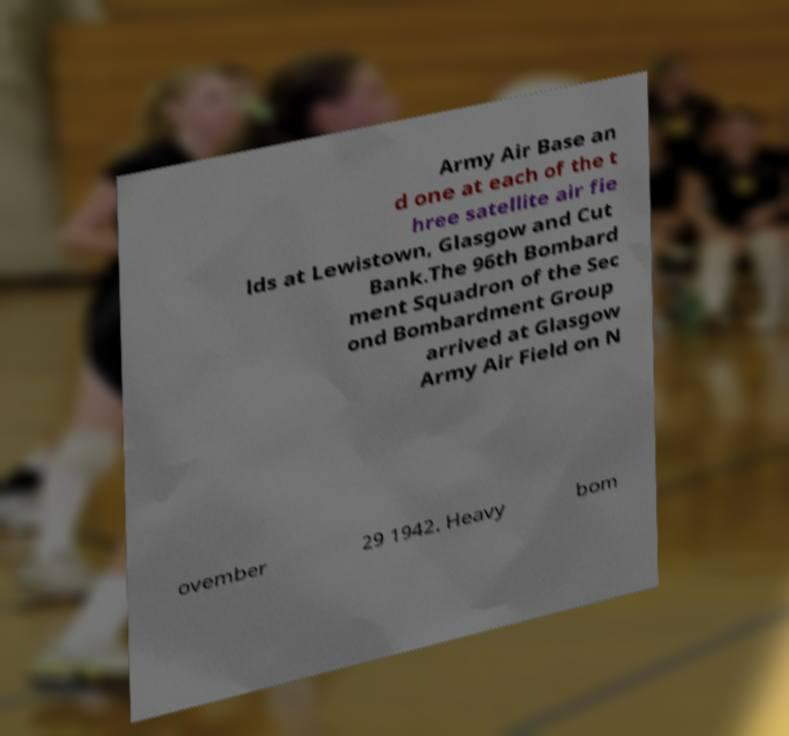I need the written content from this picture converted into text. Can you do that? Army Air Base an d one at each of the t hree satellite air fie lds at Lewistown, Glasgow and Cut Bank.The 96th Bombard ment Squadron of the Sec ond Bombardment Group arrived at Glasgow Army Air Field on N ovember 29 1942. Heavy bom 